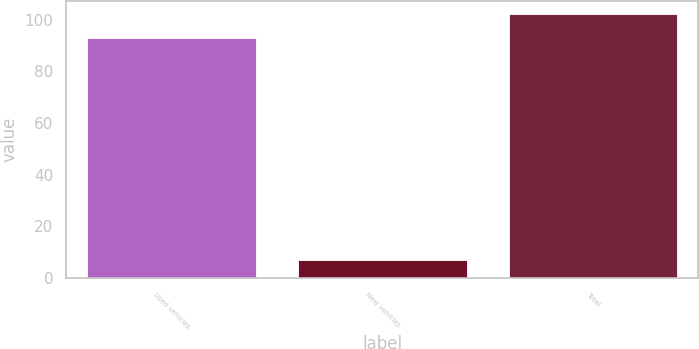<chart> <loc_0><loc_0><loc_500><loc_500><bar_chart><fcel>Used vehicles<fcel>New vehicles<fcel>Total<nl><fcel>93<fcel>7<fcel>102.3<nl></chart> 